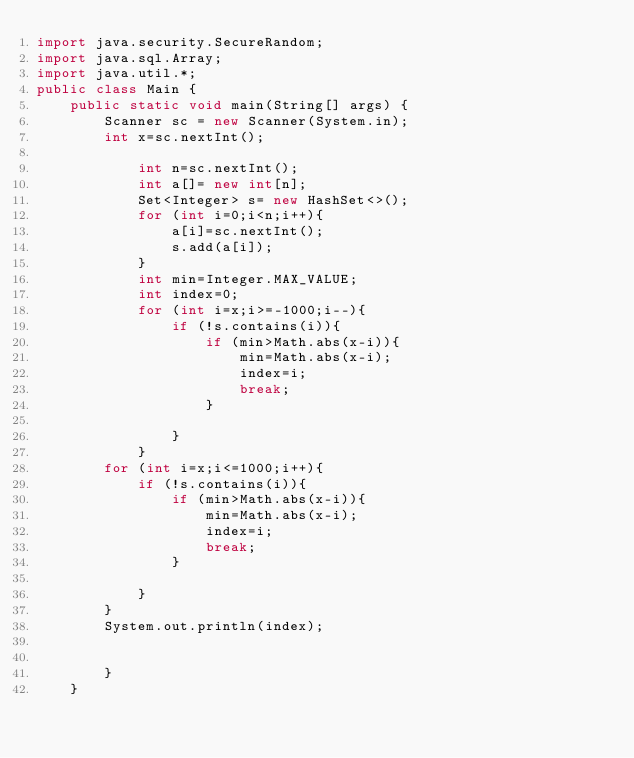Convert code to text. <code><loc_0><loc_0><loc_500><loc_500><_Java_>import java.security.SecureRandom;
import java.sql.Array;
import java.util.*;
public class Main {
    public static void main(String[] args) {
        Scanner sc = new Scanner(System.in);
        int x=sc.nextInt();

            int n=sc.nextInt();
            int a[]= new int[n];
            Set<Integer> s= new HashSet<>();
            for (int i=0;i<n;i++){
                a[i]=sc.nextInt();
                s.add(a[i]);
            }
            int min=Integer.MAX_VALUE;
            int index=0;
            for (int i=x;i>=-1000;i--){
                if (!s.contains(i)){
                    if (min>Math.abs(x-i)){
                        min=Math.abs(x-i);
                        index=i;
                        break;
                    }

                }
            }
        for (int i=x;i<=1000;i++){
            if (!s.contains(i)){
                if (min>Math.abs(x-i)){
                    min=Math.abs(x-i);
                    index=i;
                    break;
                }

            }
        }
        System.out.println(index);


        }
    }




</code> 